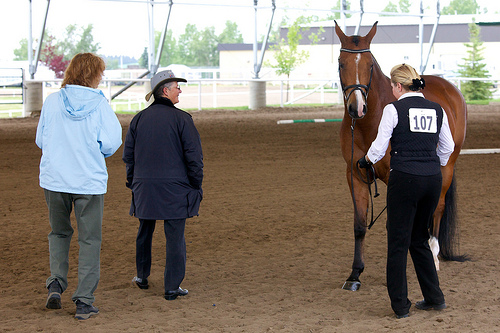<image>
Can you confirm if the horse is to the left of the ground? No. The horse is not to the left of the ground. From this viewpoint, they have a different horizontal relationship. 